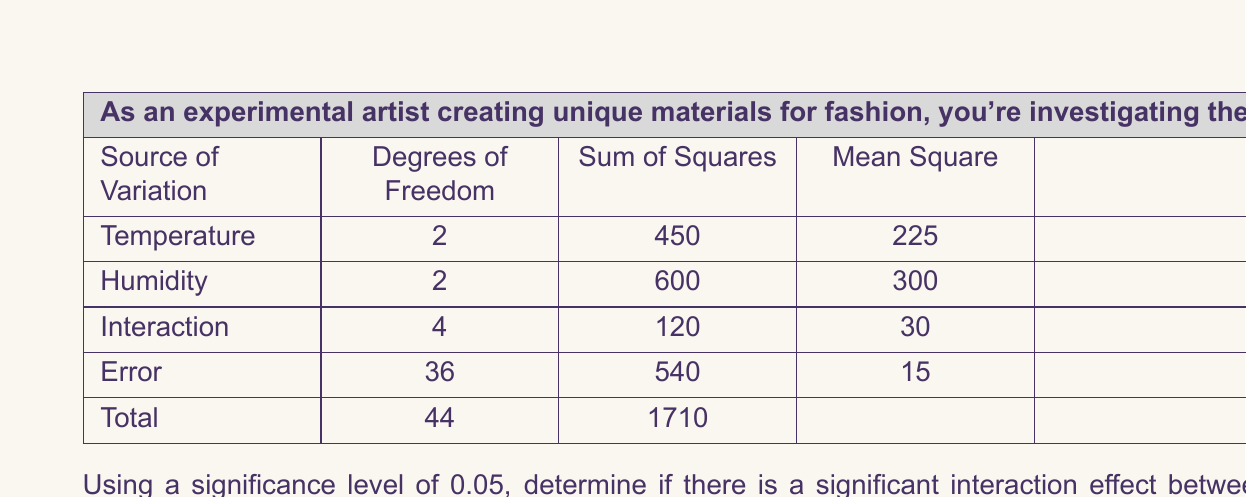What is the answer to this math problem? To determine if there is a significant interaction effect between temperature and humidity, we need to compare the calculated F-ratio for the interaction with the critical F-value from the F-distribution table.

Step 1: Identify the degrees of freedom
- Numerator degrees of freedom (df1) = 4 (from the Interaction row)
- Denominator degrees of freedom (df2) = 36 (from the Error row)

Step 2: Find the critical F-value
Using an F-distribution table with α = 0.05, df1 = 4, and df2 = 36, we find:
$$F_{critical} = F_{0.05, 4, 36} ≈ 2.63$$

Step 3: Compare the calculated F-ratio with the critical F-value
The calculated F-ratio for the interaction effect is 2 (from the ANOVA table).

Step 4: Make a decision
If the calculated F-ratio is greater than or equal to the critical F-value, we reject the null hypothesis and conclude that there is a significant interaction effect.

In this case:
$$F_{calculated} = 2 < F_{critical} = 2.63$$

Therefore, we fail to reject the null hypothesis.

Step 5: Interpret the result
Since the calculated F-ratio (2) is less than the critical F-value (2.63), we do not have sufficient evidence to conclude that there is a significant interaction effect between temperature and humidity on the elasticity of the novel textile blend at the 0.05 significance level.

This means that the effect of temperature on elasticity does not significantly depend on the humidity level, and vice versa. The factors may still have individual effects on elasticity, but their combined effect is not statistically significant.
Answer: There is no significant interaction effect between temperature and humidity on the elasticity of the novel textile blend at the 0.05 significance level (F(4, 36) = 2, p > 0.05). 